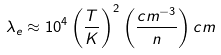Convert formula to latex. <formula><loc_0><loc_0><loc_500><loc_500>\lambda _ { e } \approx 1 0 ^ { 4 } \left ( \frac { T } { K } \right ) ^ { 2 } \left ( \frac { c m ^ { - 3 } } { n } \right ) c m</formula> 